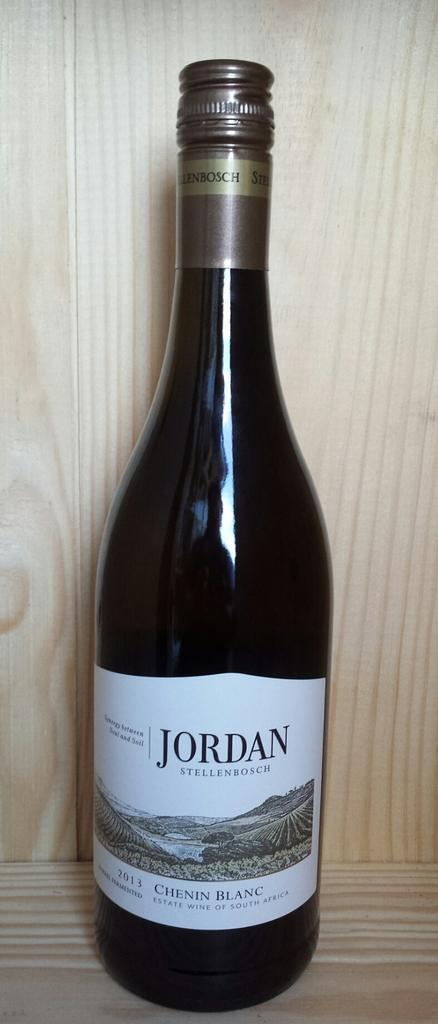Provide a one-sentence caption for the provided image. a bottle of Jordan Stellenbosch Chenin Blanc wine from South Africa. 